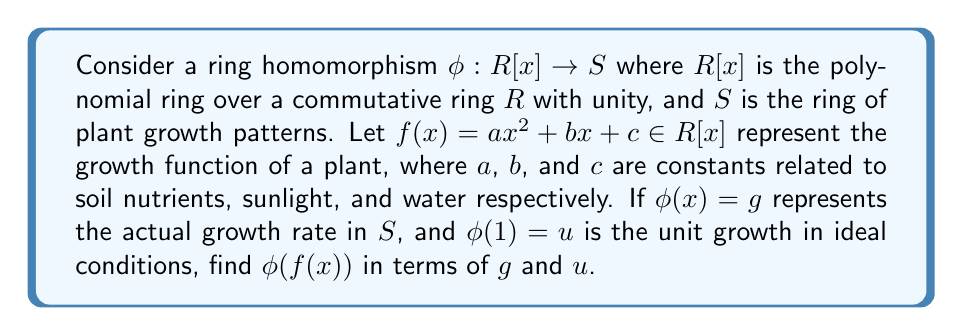Teach me how to tackle this problem. To solve this problem, we'll use the properties of ring homomorphisms and apply them to our specific scenario:

1) First, recall that a ring homomorphism preserves addition and multiplication:
   $\phi(r + s) = \phi(r) + \phi(s)$ and $\phi(rs) = \phi(r)\phi(s)$ for all $r, s \in R[x]$

2) We're given that $\phi(x) = g$ and $\phi(1) = u$. Note that $\phi(1)$ is the multiplicative identity in $S$.

3) Now, let's break down $f(x) = ax^2 + bx + c$:

   $\phi(f(x)) = \phi(ax^2 + bx + c)$

4) Using the additivity of ring homomorphisms:

   $\phi(f(x)) = \phi(ax^2) + \phi(bx) + \phi(c)$

5) Now, let's handle each term separately:

   a) $\phi(ax^2) = \phi(a)\phi(x^2) = \phi(a)\phi(x)\phi(x) = \phi(a)g^2$
   b) $\phi(bx) = \phi(b)\phi(x) = \phi(b)g$
   c) $\phi(c) = \phi(c)u$ (since $\phi(c) = \phi(c)\phi(1) = \phi(c)u$)

6) Combining these results:

   $\phi(f(x)) = \phi(a)g^2 + \phi(b)g + \phi(c)u$

This expression represents the actual growth pattern in $S$ based on the ideal growth function $f(x)$ in $R[x]$.
Answer: $\phi(f(x)) = \phi(a)g^2 + \phi(b)g + \phi(c)u$ 